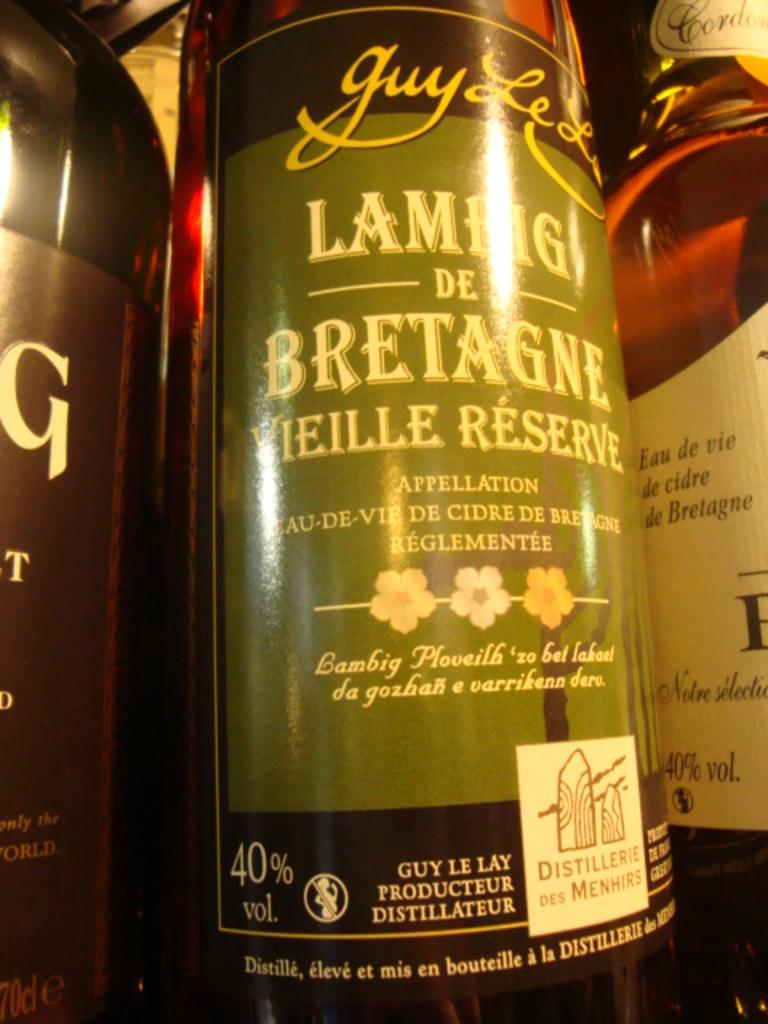<image>
Relay a brief, clear account of the picture shown. A bottle with Lambig de Bretagne written on it. 